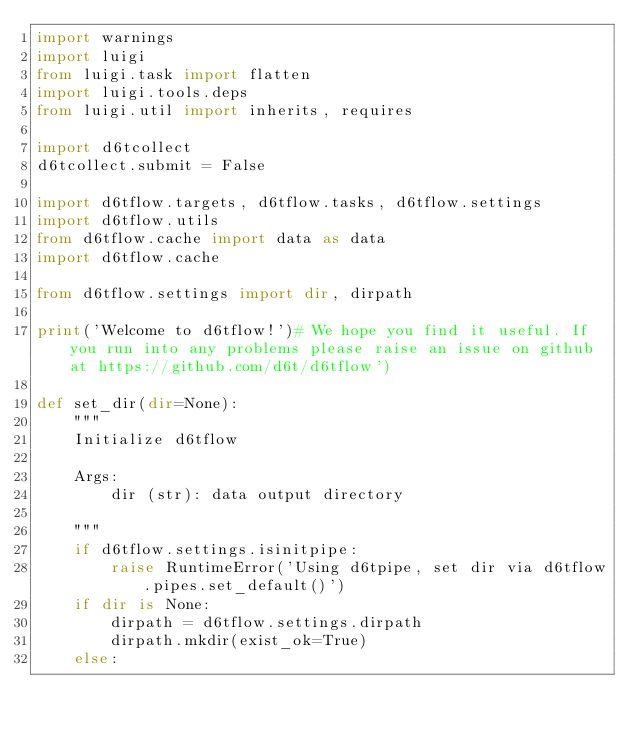Convert code to text. <code><loc_0><loc_0><loc_500><loc_500><_Python_>import warnings
import luigi
from luigi.task import flatten
import luigi.tools.deps
from luigi.util import inherits, requires

import d6tcollect
d6tcollect.submit = False

import d6tflow.targets, d6tflow.tasks, d6tflow.settings
import d6tflow.utils
from d6tflow.cache import data as data
import d6tflow.cache

from d6tflow.settings import dir, dirpath

print('Welcome to d6tflow!')# We hope you find it useful. If you run into any problems please raise an issue on github at https://github.com/d6t/d6tflow')

def set_dir(dir=None):
    """
    Initialize d6tflow

    Args:
        dir (str): data output directory

    """
    if d6tflow.settings.isinitpipe:
        raise RuntimeError('Using d6tpipe, set dir via d6tflow.pipes.set_default()')
    if dir is None:
        dirpath = d6tflow.settings.dirpath
        dirpath.mkdir(exist_ok=True)
    else:</code> 